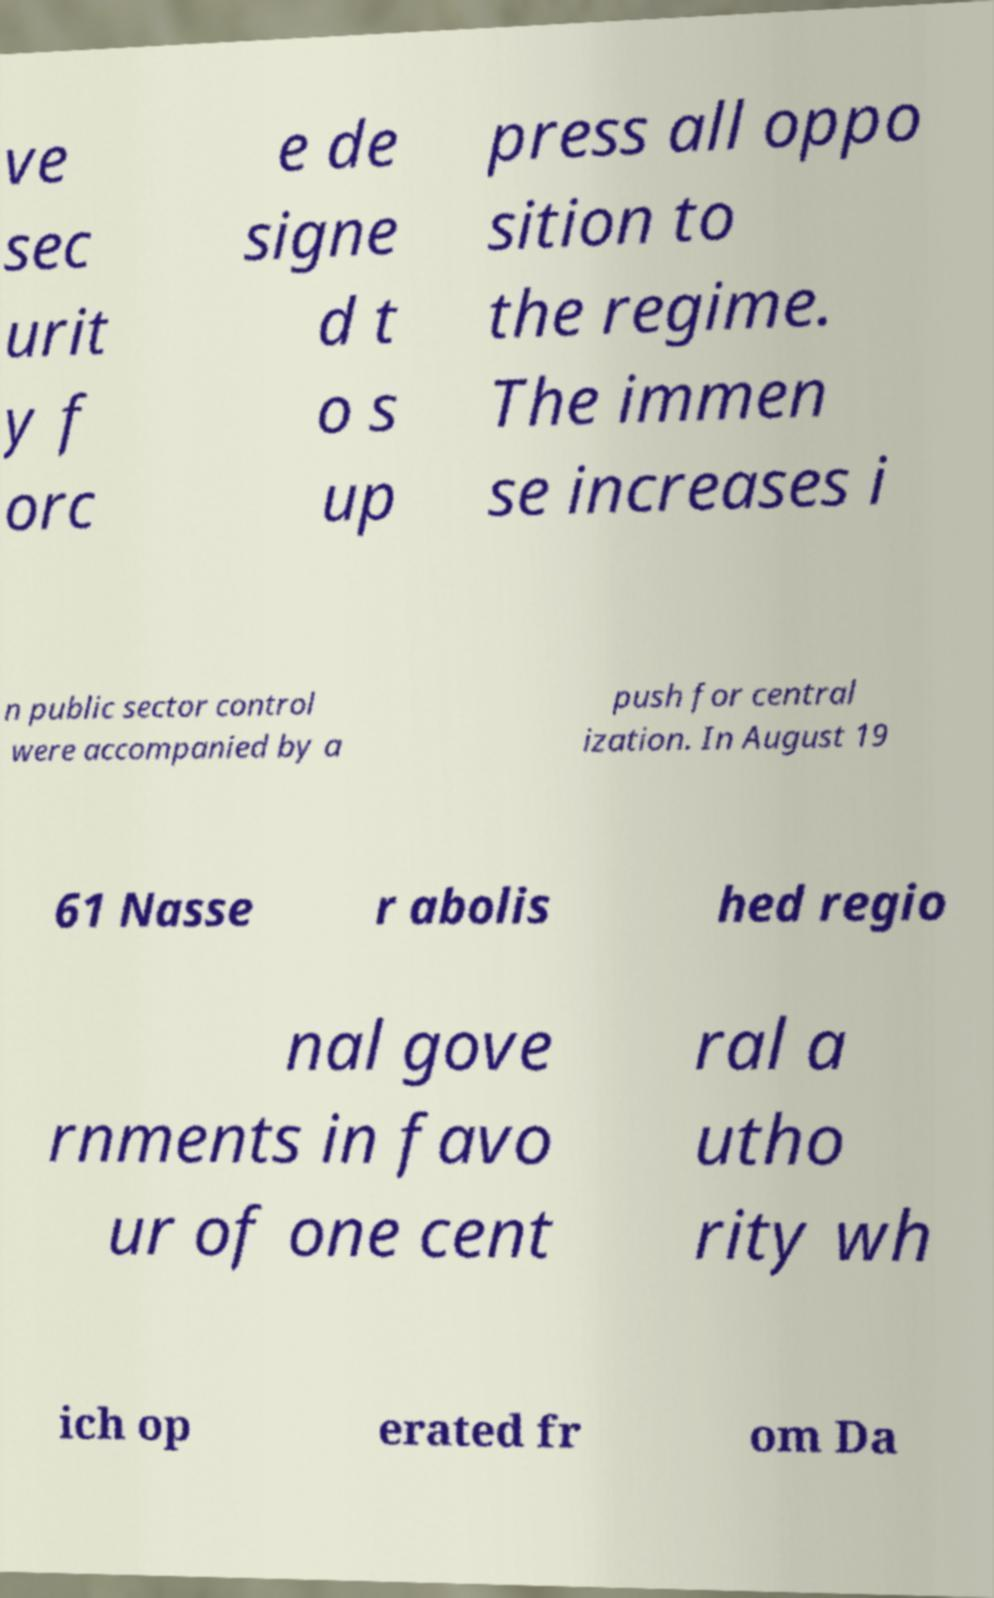What messages or text are displayed in this image? I need them in a readable, typed format. ve sec urit y f orc e de signe d t o s up press all oppo sition to the regime. The immen se increases i n public sector control were accompanied by a push for central ization. In August 19 61 Nasse r abolis hed regio nal gove rnments in favo ur of one cent ral a utho rity wh ich op erated fr om Da 